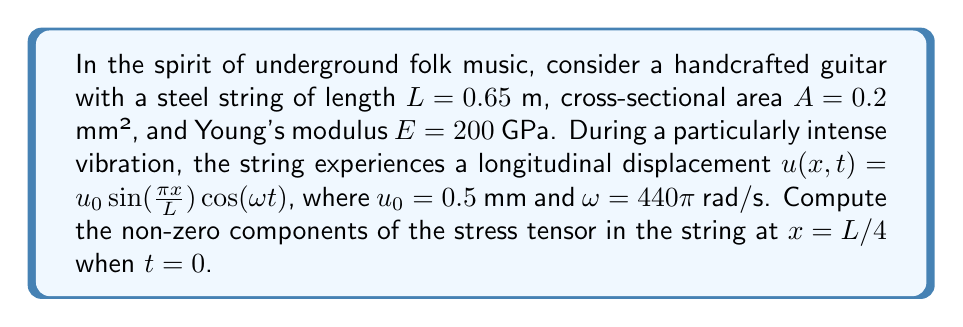Give your solution to this math problem. Let's approach this step-by-step:

1) In a vibrating guitar string, we're primarily concerned with the longitudinal stress. The stress tensor will have only one non-zero component, $\sigma_{xx}$, along the length of the string.

2) The stress is related to strain by Hooke's law:

   $$\sigma_{xx} = E \epsilon_{xx}$$

   where $E$ is Young's modulus and $\epsilon_{xx}$ is the longitudinal strain.

3) The strain is defined as the derivative of displacement with respect to position:

   $$\epsilon_{xx} = \frac{\partial u}{\partial x}$$

4) We need to differentiate $u(x,t)$ with respect to $x$:

   $$\frac{\partial u}{\partial x} = u_0 \frac{\pi}{L} \cos(\frac{\pi x}{L}) \cos(\omega t)$$

5) At $x = L/4$ and $t = 0$:

   $$\epsilon_{xx} = u_0 \frac{\pi}{L} \cos(\frac{\pi}{4}) \cos(0) = u_0 \frac{\pi}{L} \frac{\sqrt{2}}{2}$$

6) Substituting the given values:

   $$\epsilon_{xx} = 0.0005 \cdot \frac{\pi}{0.65} \cdot \frac{\sqrt{2}}{2} = 1.697 \times 10^{-3}$$

7) Now we can calculate the stress:

   $$\sigma_{xx} = E \epsilon_{xx} = (200 \times 10^9) \cdot (1.697 \times 10^{-3}) = 339.4 \times 10^6 \text{ Pa}$$

Therefore, the only non-zero component of the stress tensor is $\sigma_{xx} = 339.4$ MPa.
Answer: $\sigma_{xx} = 339.4$ MPa, all other components zero 